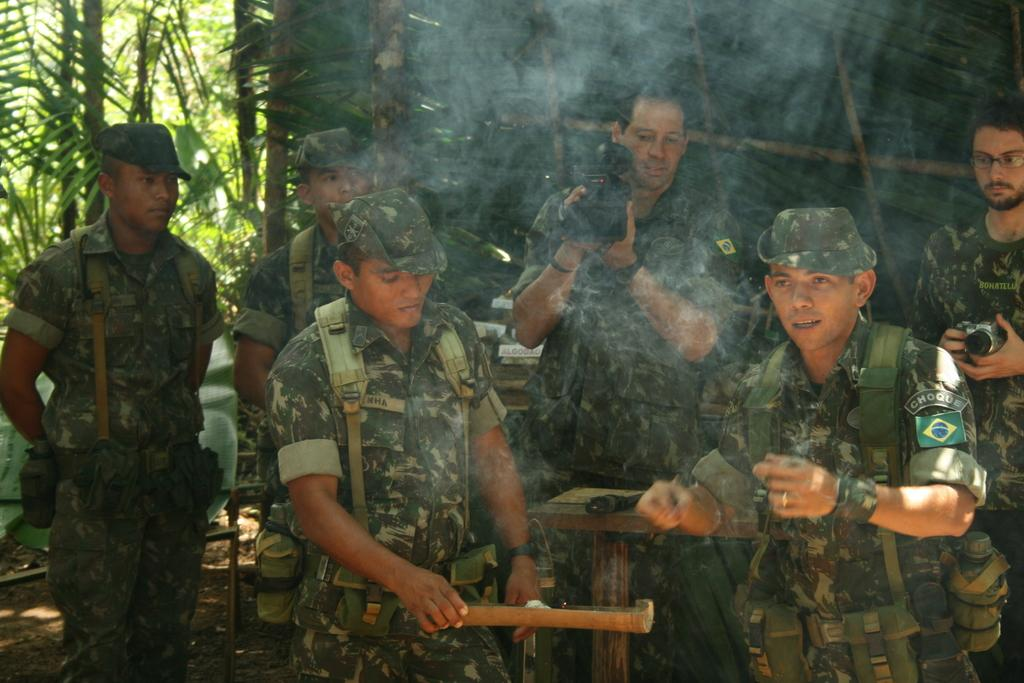How many people are in the image? There are people in the image, but the exact number is not specified. What are two people doing in the image? Two people are holding cameras in the image. What can be seen at the left top of the image? There is a tree at the left top of the image. What material is visible in the image? Wood is visible in the image. What type of chain can be seen connecting the two people holding cameras in the image? There is no chain visible in the image connecting the two people holding cameras. What type of yoke is being used by the people in the image? There is no yoke present in the image. 